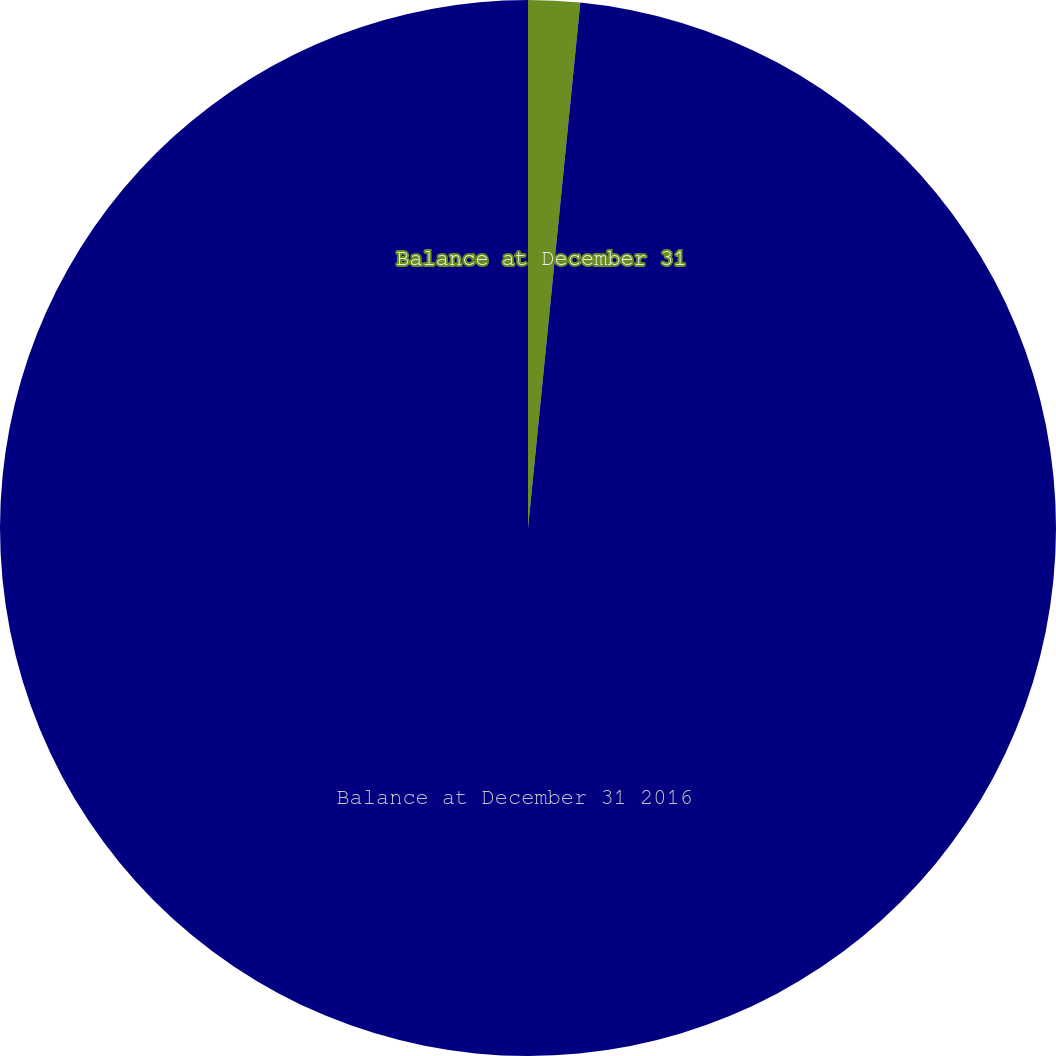Convert chart to OTSL. <chart><loc_0><loc_0><loc_500><loc_500><pie_chart><fcel>Balance at December 31<fcel>Balance at December 31 2016<nl><fcel>1.58%<fcel>98.42%<nl></chart> 